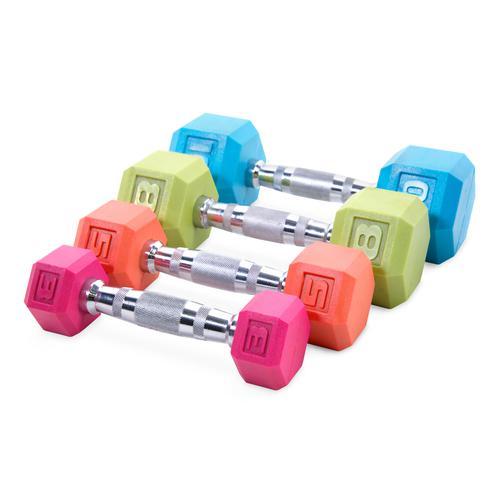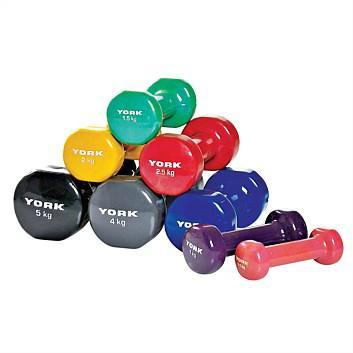The first image is the image on the left, the second image is the image on the right. Assess this claim about the two images: "There are no more than three weights in the image on the right.". Correct or not? Answer yes or no. No. The first image is the image on the left, the second image is the image on the right. For the images shown, is this caption "An image shows a neat row of dumbbells arranged by weight that includes at least four different colored ends." true? Answer yes or no. Yes. 